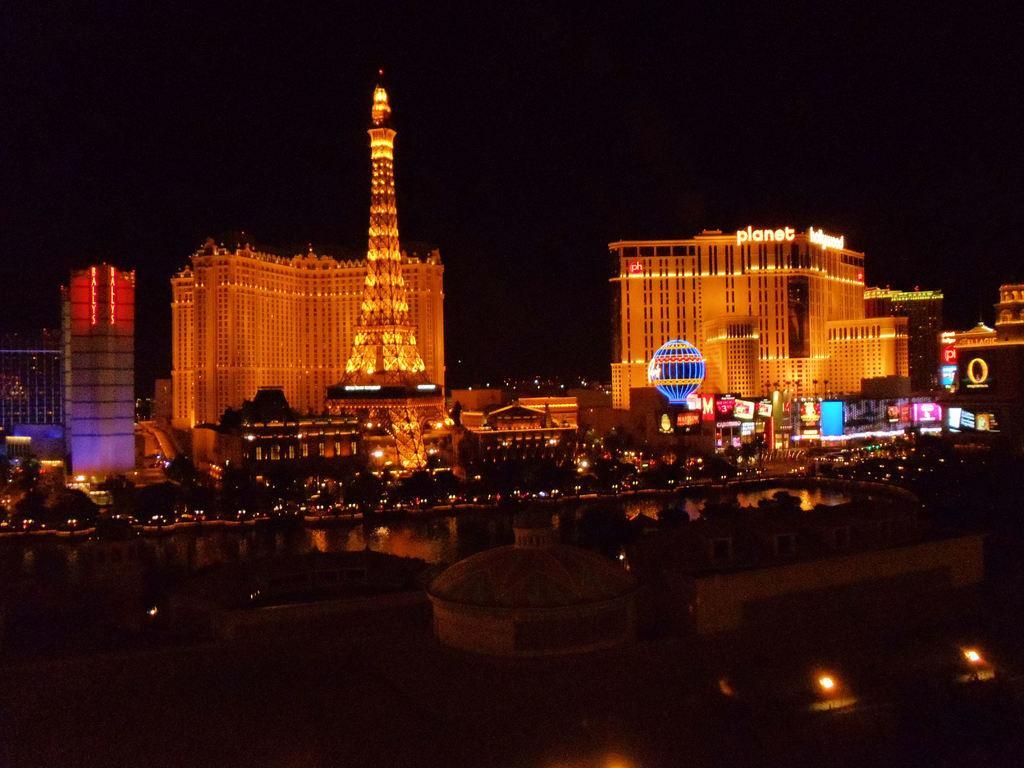Describe this image in one or two sentences. In the picture there is some architecture in the front and there is a water surface behind the architecture and there are few trees around the water surface, in the background there are beautiful buildings and there is a tower in front of one of the building. 